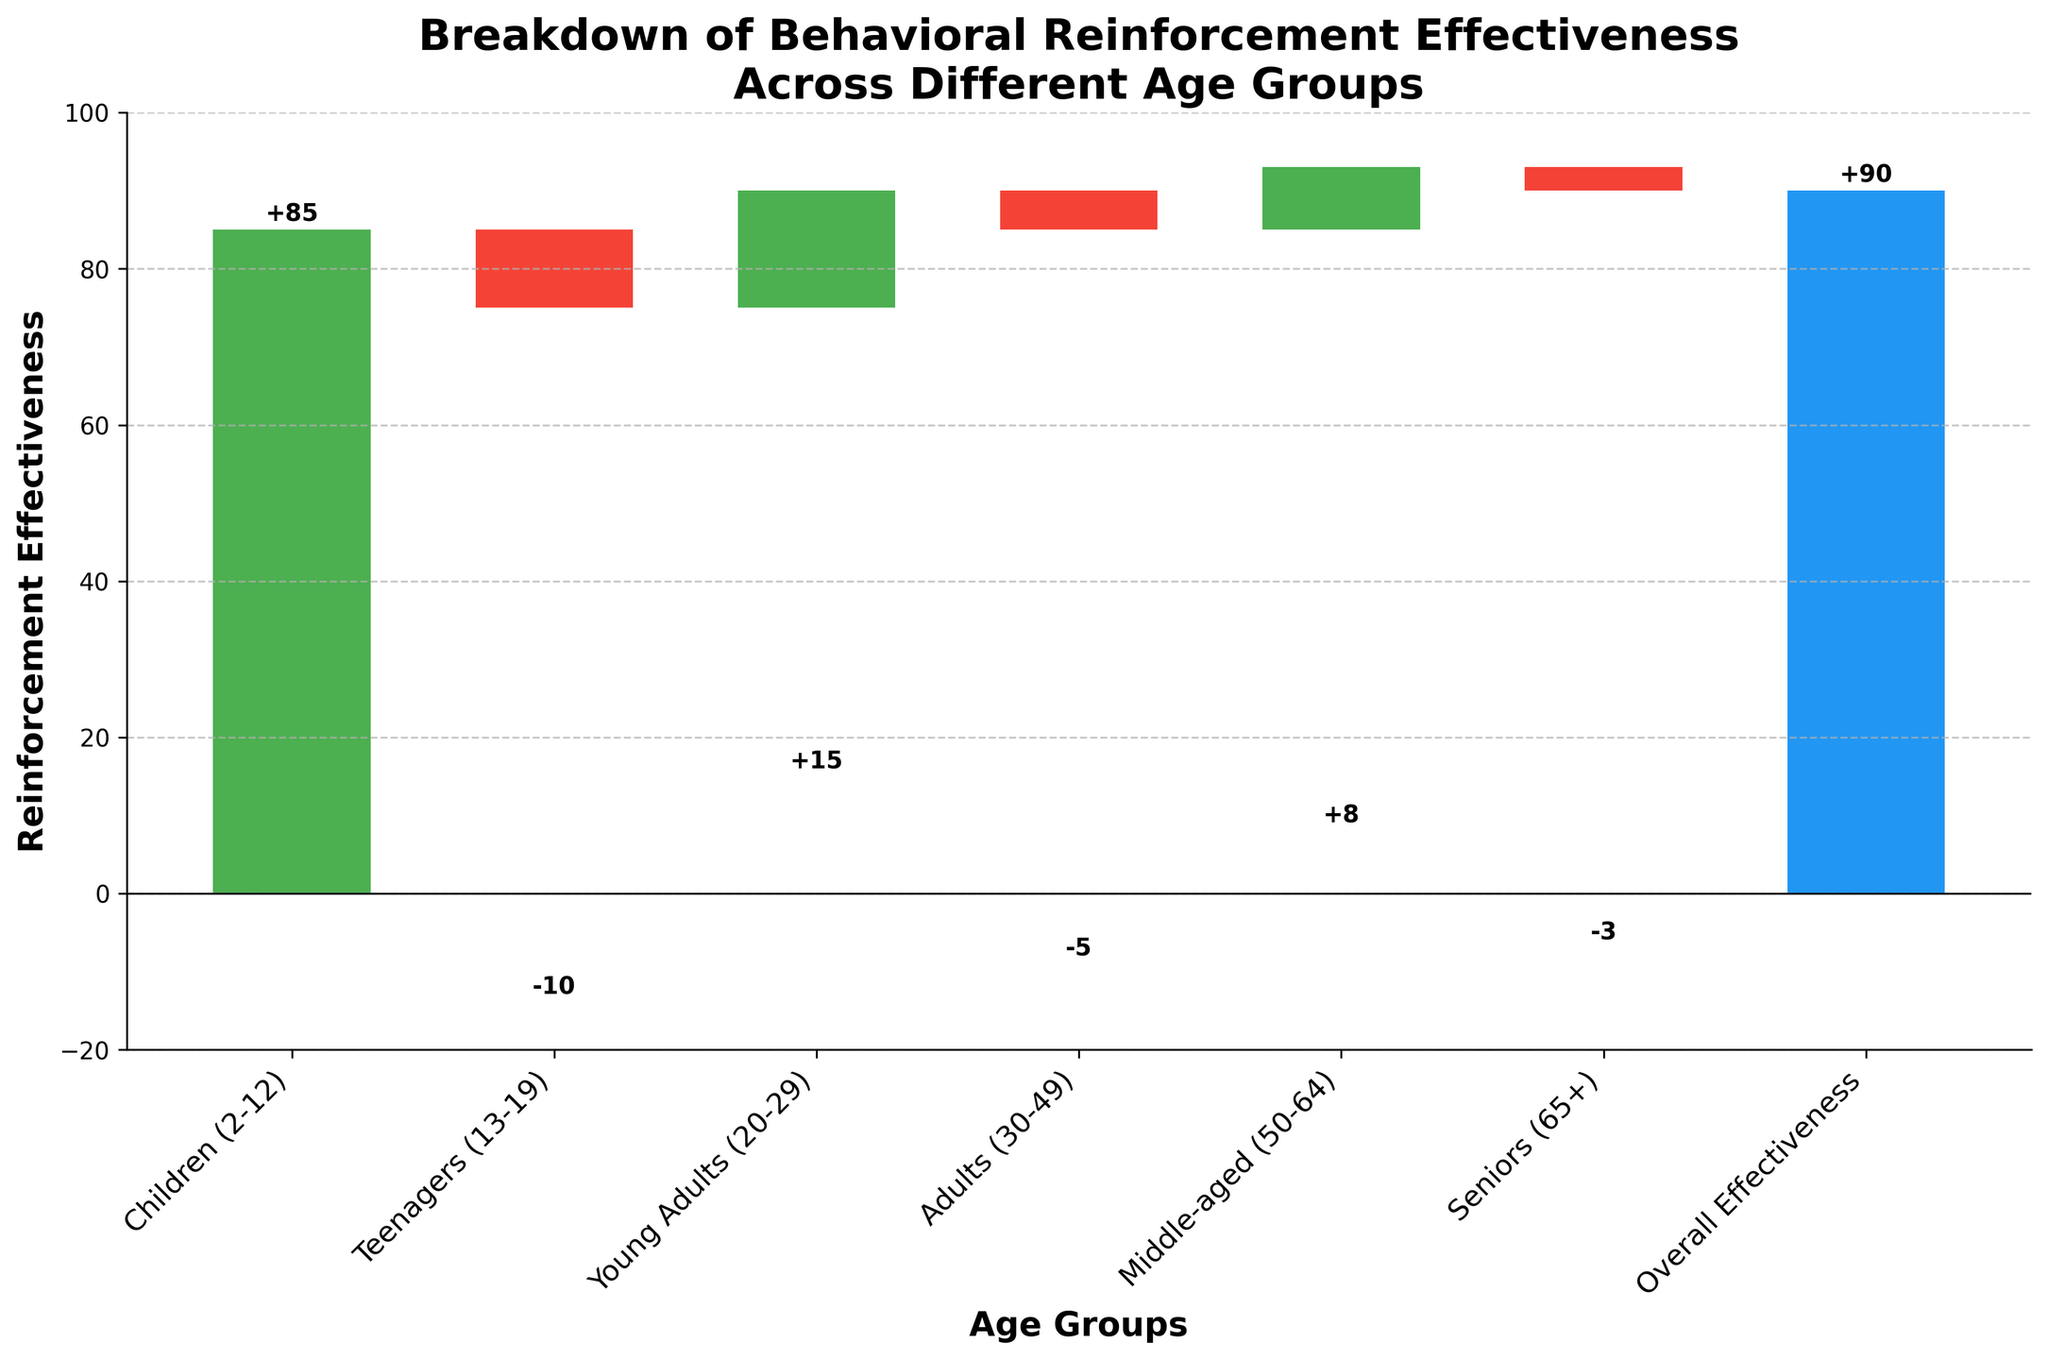What is the title of the figure? The title of the figure is prominently displayed at the top of the chart and reads "Breakdown of Behavioral Reinforcement Effectiveness Across Different Age Groups."
Answer: Breakdown of Behavioral Reinforcement Effectiveness Across Different Age Groups Which age group has the highest reinforcement effectiveness? By looking at the heights of the bars, the age group "Children (2-12)" has the highest reinforcement effectiveness, indicated by the tallest green bar at 85.
Answer: Children (2-12) What is the difference in reinforcement effectiveness between Teenagers (13-19) and Middle-aged (50-64)? The effectiveness for Teenagers is -10, and for Middle-aged is 8. Calculate the difference: 8 - (-10) = 8 + 10 = 18.
Answer: 18 How many age groups show negative reinforcement effectiveness? By examining the color of the bars, the groups "Teenagers (13-19)", "Adults (30-49)", and "Seniors (65+)" have red bars, indicating negative effectiveness. Count these bars: 3.
Answer: 3 What is the overall reinforcement effectiveness according to the chart? The final bar, labeled "Overall Effectiveness," shows the value which is the sum of all other data points, and it reads as 90.
Answer: 90 Compare the reinforcement effectiveness between Young Adults (20-29) and Adults (30-49). Which group is more effective? The effectiveness for Young Adults is 15, and for Adults, it is -5. Since 15 is greater than -5, Young Adults have higher reinforcement effectiveness.
Answer: Young Adults (20-29) If we sum the effectiveness of Children (2-12) and Seniors (65+), what is the result? The effectiveness for Children is 85, and for Seniors it is -3. Calculate the sum: 85 + (-3) = 85 - 3 = 82.
Answer: 82 What is the net increase or decrease in reinforcement effectiveness from Children (2-12) to Seniors (65+)? Calculate the cumulative change from each group sequentially, starting from 85 for Children and summing all changes: 85 - 10 + 15 - 5 + 8 - 3 = 90.
Answer: 90 Which age group represents the sum of all its preceding groups in the waterfall chart model? In a waterfall chart, the final cumulative value is often the sum of all previous values, represented by the "Overall Effectiveness," which sums to 90.
Answer: Overall Effectiveness How many age groups have a positive reinforcement effectiveness? By examining the positive green bars, the groups are: "Children (2-12)", "Young Adults (20-29)", and "Middle-aged (50-64)". Count these bars: 3.
Answer: 3 